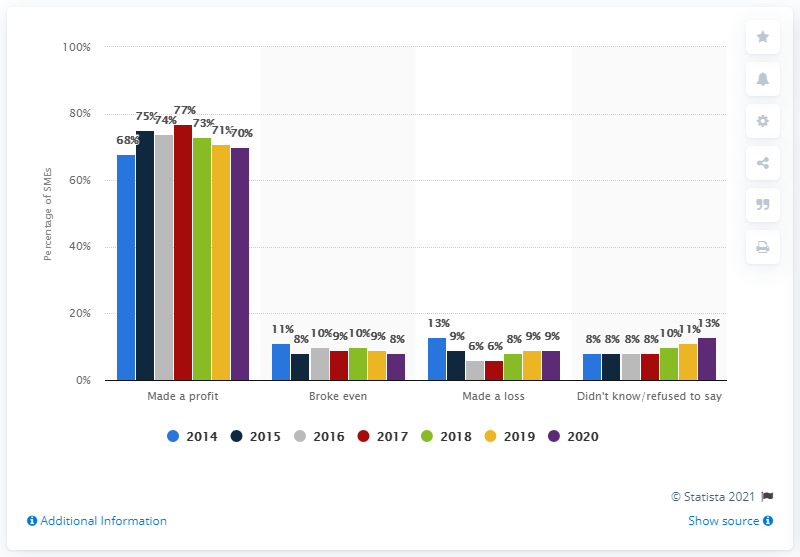Specify some key components in this picture. According to the data provided, a significant majority of SMEs, or small and medium-sized enterprises, reported making a net profit in the previous 12 months, with 70% of them reporting net profits. 